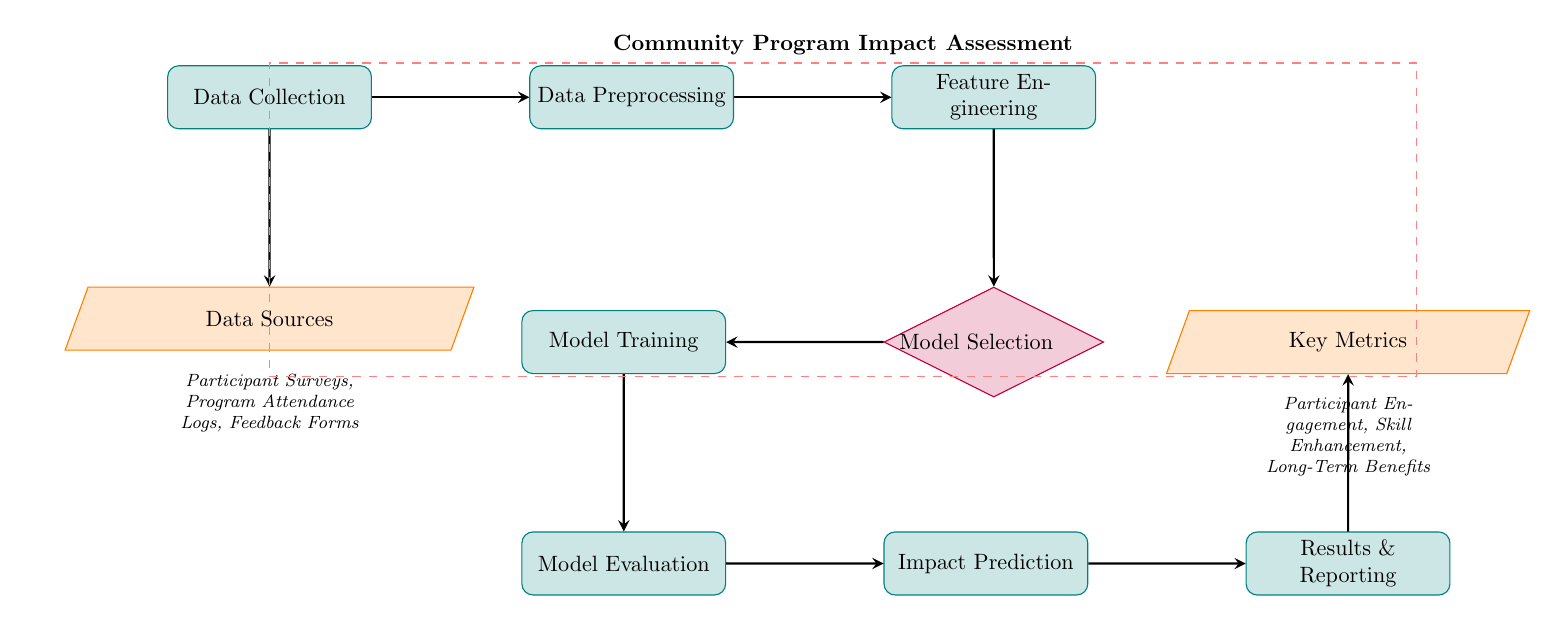What is the first step in the process? The first step in the diagram, labeled as "Data Collection," indicates the initial stage of assessing the community program's impact.
Answer: Data Collection How many key metrics are identified in the diagram? The diagram identifies three key metrics listed under “Key Metrics”: Participant Engagement, Skill Enhancement, and Long-Term Benefits, indicating a total of three metrics.
Answer: Three What follows feature engineering in the model flow? After the "Feature Engineering" node, the next node in the flowchart is "Model Selection," demonstrating the sequential nature of the process.
Answer: Model Selection What type of data is collected from participants? The "Data Sources" node specifies that the data collected includes information from "Participant Surveys, Program Attendance Logs, Feedback Forms."
Answer: Participant Surveys, Program Attendance Logs, Feedback Forms What are the final outputs of the machine learning model? The diagram lists "Results & Reporting" as the output following "Impact Prediction," which represents the conclusions drawn from the model's assessment of community program effectiveness.
Answer: Results & Reporting Which stage involves determining the appropriate algorithm for the data? The "Model Selection" node is where the appropriate algorithm is determined for processing the data within the context of assessing program effectiveness.
Answer: Model Selection What is the purpose of the "Evaluation" step? The "Evaluation" step is used to assess how well the trained model performs, ensuring its reliability before making predictions about program impact.
Answer: To assess the model's performance Which node precedes "Impact Prediction"? "Evaluation" is the step that directly precedes "Impact Prediction" in the flow of the diagram, indicating a chronological order of operations.
Answer: Evaluation What do the metrics aim to measure? The key metrics aim to measure "Participant Engagement, Skill Enhancement, Long-Term Benefits," which reflect the efficacy of the community programs.
Answer: Participant Engagement, Skill Enhancement, Long-Term Benefits 